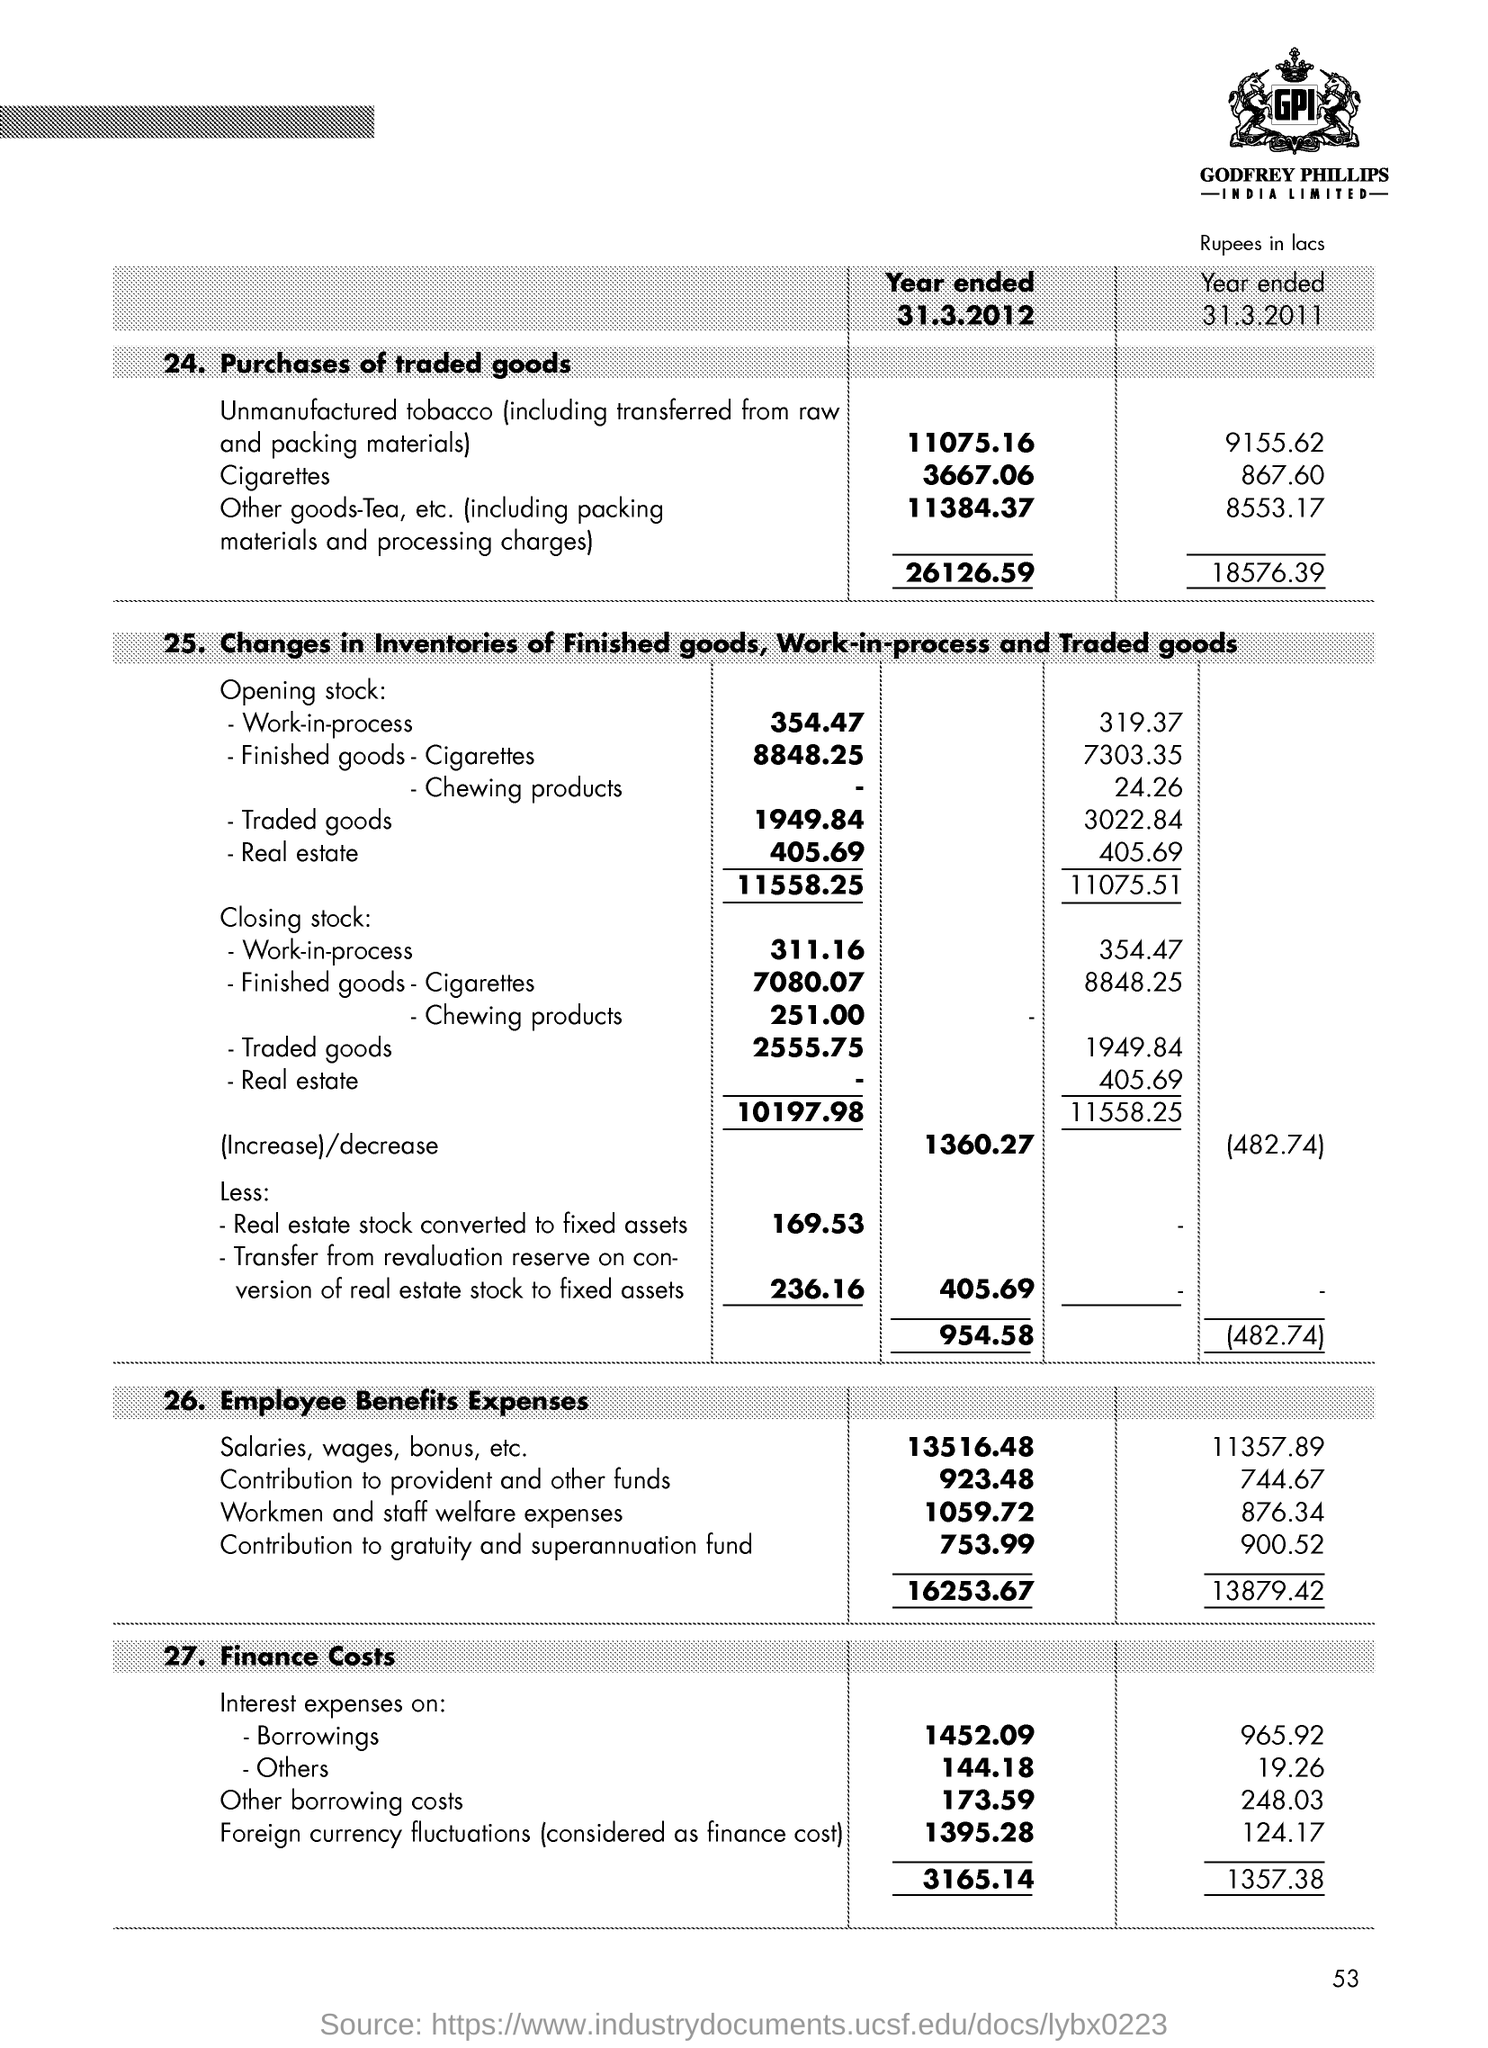What is the Finance Cost for Interest expenses on Borrowings for Year ended 31.3.2012?
Ensure brevity in your answer.  1452.09. What is the Finance Cost for Interest expenses on others for Year ended 31.3.2012?
Offer a terse response. 144.18. What is the Finance Cost for Interest expenses on others for Year ended 31.3.2011?
Offer a very short reply. 19.26. 